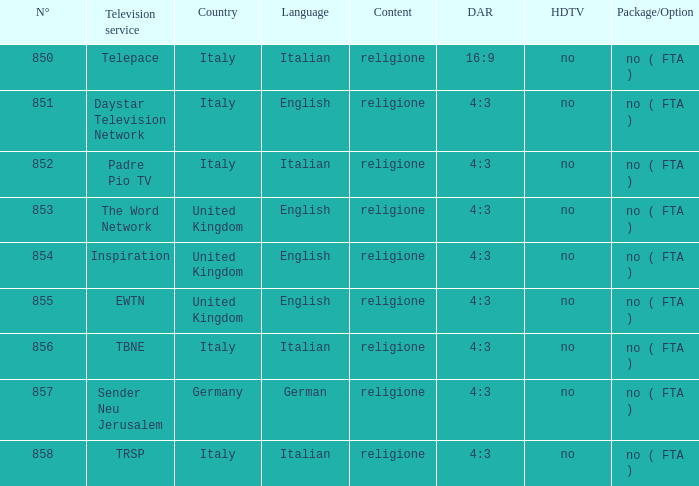Write the full table. {'header': ['N°', 'Television service', 'Country', 'Language', 'Content', 'DAR', 'HDTV', 'Package/Option'], 'rows': [['850', 'Telepace', 'Italy', 'Italian', 'religione', '16:9', 'no', 'no ( FTA )'], ['851', 'Daystar Television Network', 'Italy', 'English', 'religione', '4:3', 'no', 'no ( FTA )'], ['852', 'Padre Pio TV', 'Italy', 'Italian', 'religione', '4:3', 'no', 'no ( FTA )'], ['853', 'The Word Network', 'United Kingdom', 'English', 'religione', '4:3', 'no', 'no ( FTA )'], ['854', 'Inspiration', 'United Kingdom', 'English', 'religione', '4:3', 'no', 'no ( FTA )'], ['855', 'EWTN', 'United Kingdom', 'English', 'religione', '4:3', 'no', 'no ( FTA )'], ['856', 'TBNE', 'Italy', 'Italian', 'religione', '4:3', 'no', 'no ( FTA )'], ['857', 'Sender Neu Jerusalem', 'Germany', 'German', 'religione', '4:3', 'no', 'no ( FTA )'], ['858', 'TRSP', 'Italy', 'Italian', 'religione', '4:3', 'no', 'no ( FTA )']]} What television platforms can be found in the uk and hold a number surpassing 85 EWTN. 